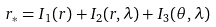<formula> <loc_0><loc_0><loc_500><loc_500>r _ { * } = I _ { 1 } ( r ) + I _ { 2 } ( r , \lambda ) + I _ { 3 } ( \theta , \lambda )</formula> 